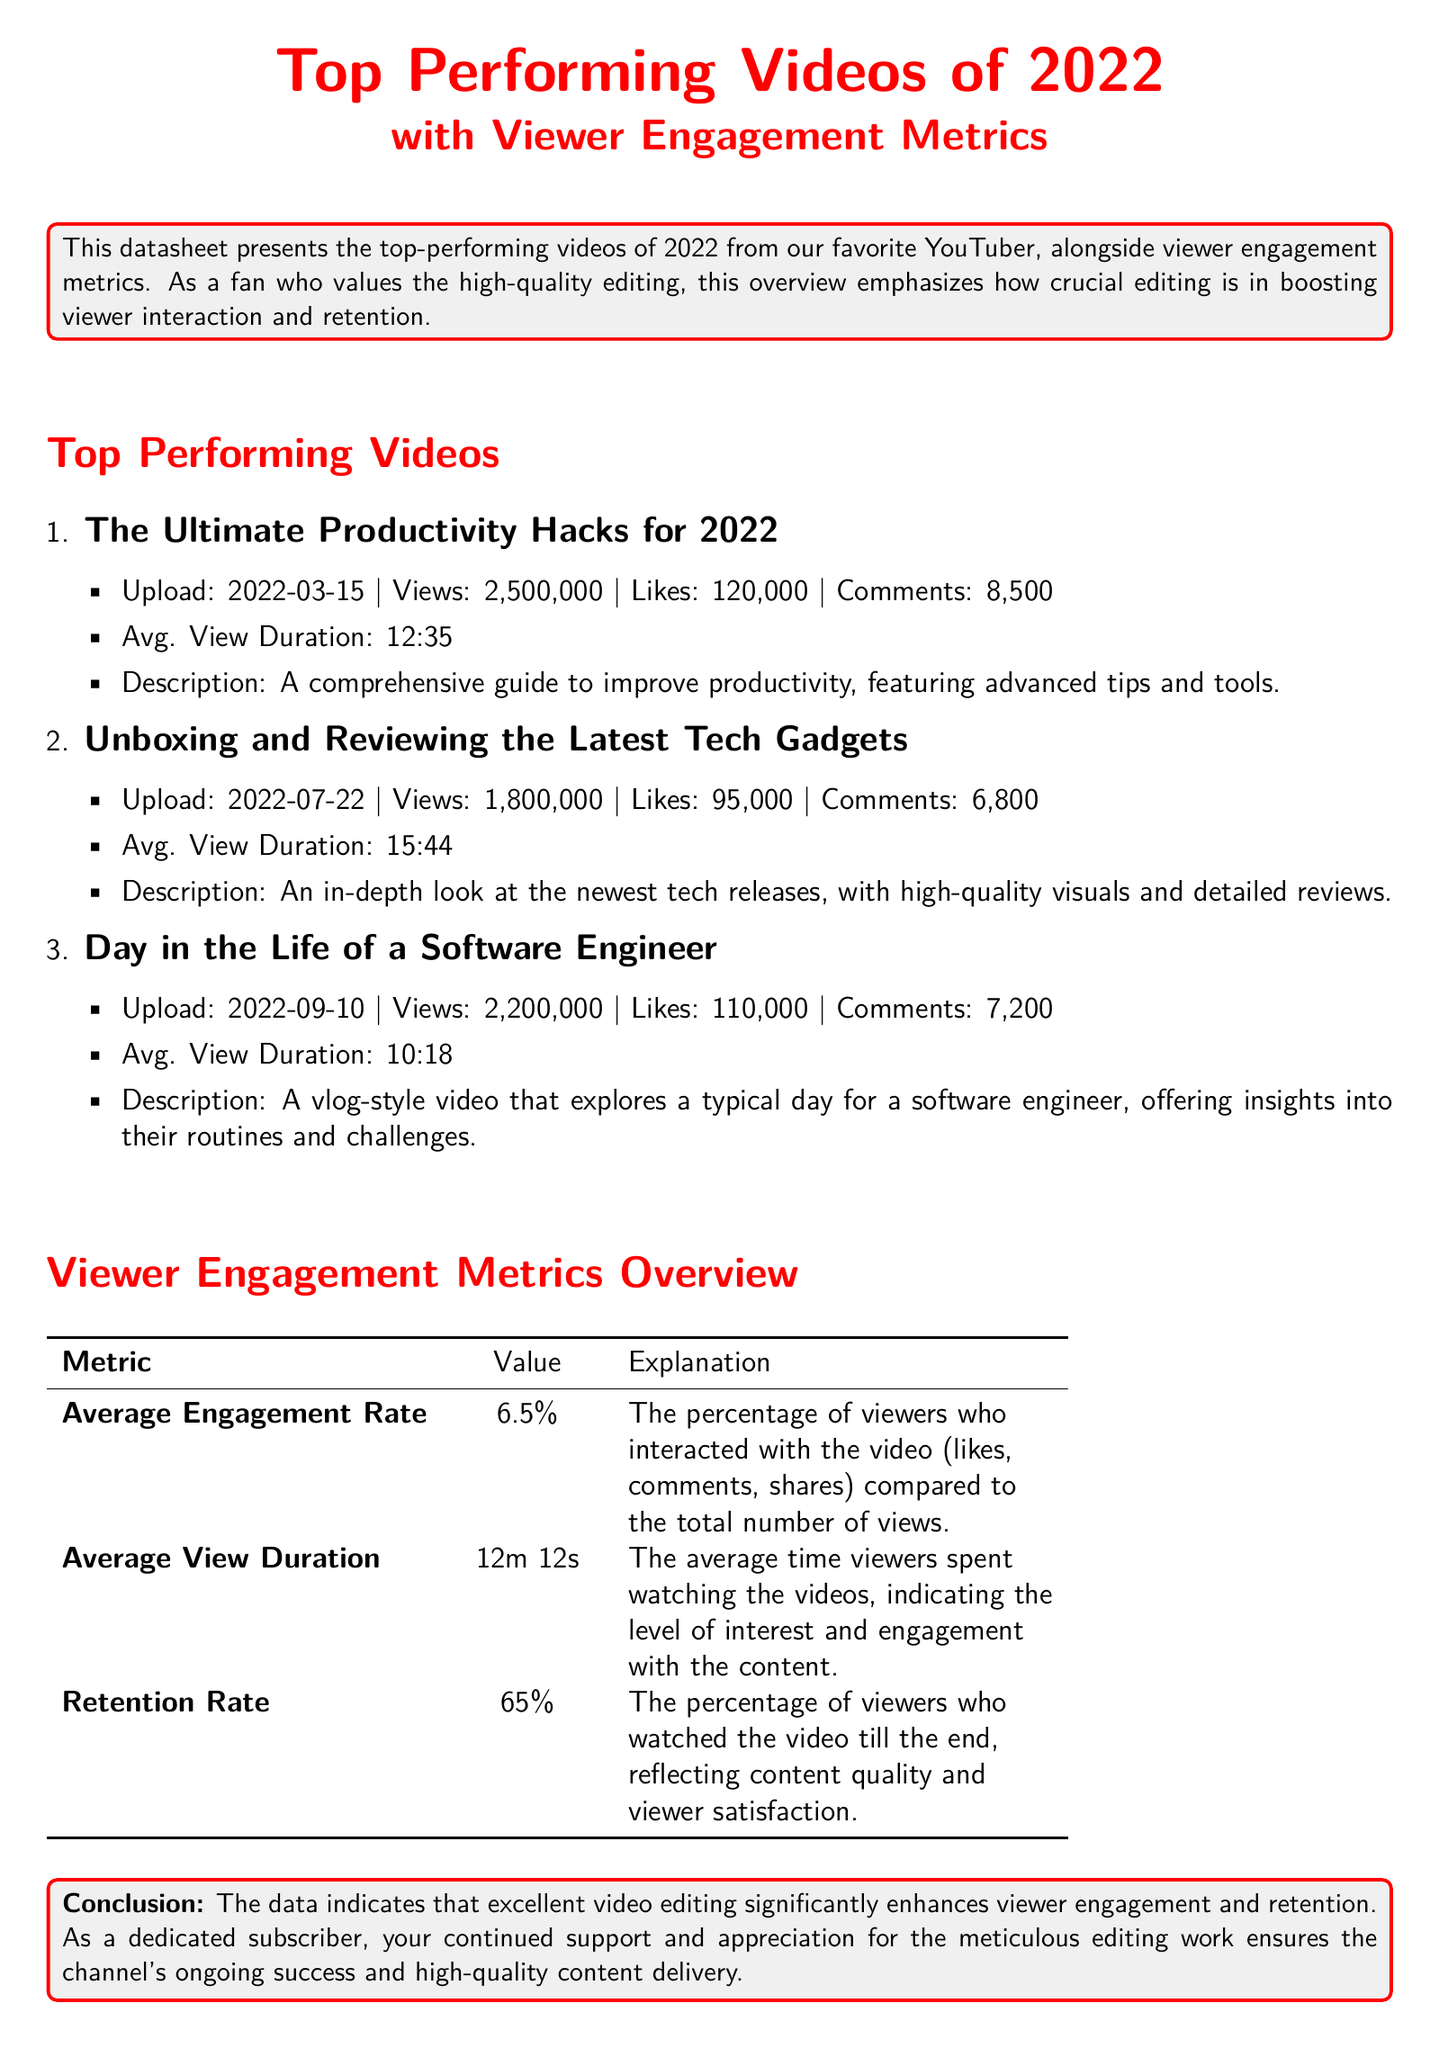What is the title of the most viewed video? The title of the most viewed video can be found in the list of top-performing videos, focusing on the highest view count.
Answer: The Ultimate Productivity Hacks for 2022 How many likes did the Unboxing video receive? The number of likes for the Unboxing video is listed alongside its view metrics in the document.
Answer: 95,000 What was the average view duration of the video titled 'Day in the Life of a Software Engineer'? The average view duration is provided for each video in the details listed in the document.
Answer: 10:18 What is the average engagement rate of the videos? The average engagement rate is summarized in the Viewer Engagement Metrics Overview section of the document.
Answer: 6.5% What is the retention rate mentioned in the document? The retention rate is provided in the Viewer Engagement Metrics Overview section and represents viewer satisfaction.
Answer: 65% When was the 'Unboxing and Reviewing the Latest Tech Gadgets' video uploaded? The upload date for each video is stated in the specific details of each listed video.
Answer: 2022-07-22 Which video has the highest average view duration? The average view duration for each video is indicated, allowing for the determination of which video retained viewers the longest.
Answer: Unboxing and Reviewing the Latest Tech Gadgets What conclusion is drawn about the impact of editing? The conclusion summarizes the document's focus on viewer engagement and editing quality.
Answer: Excellent video editing significantly enhances viewer engagement and retention 